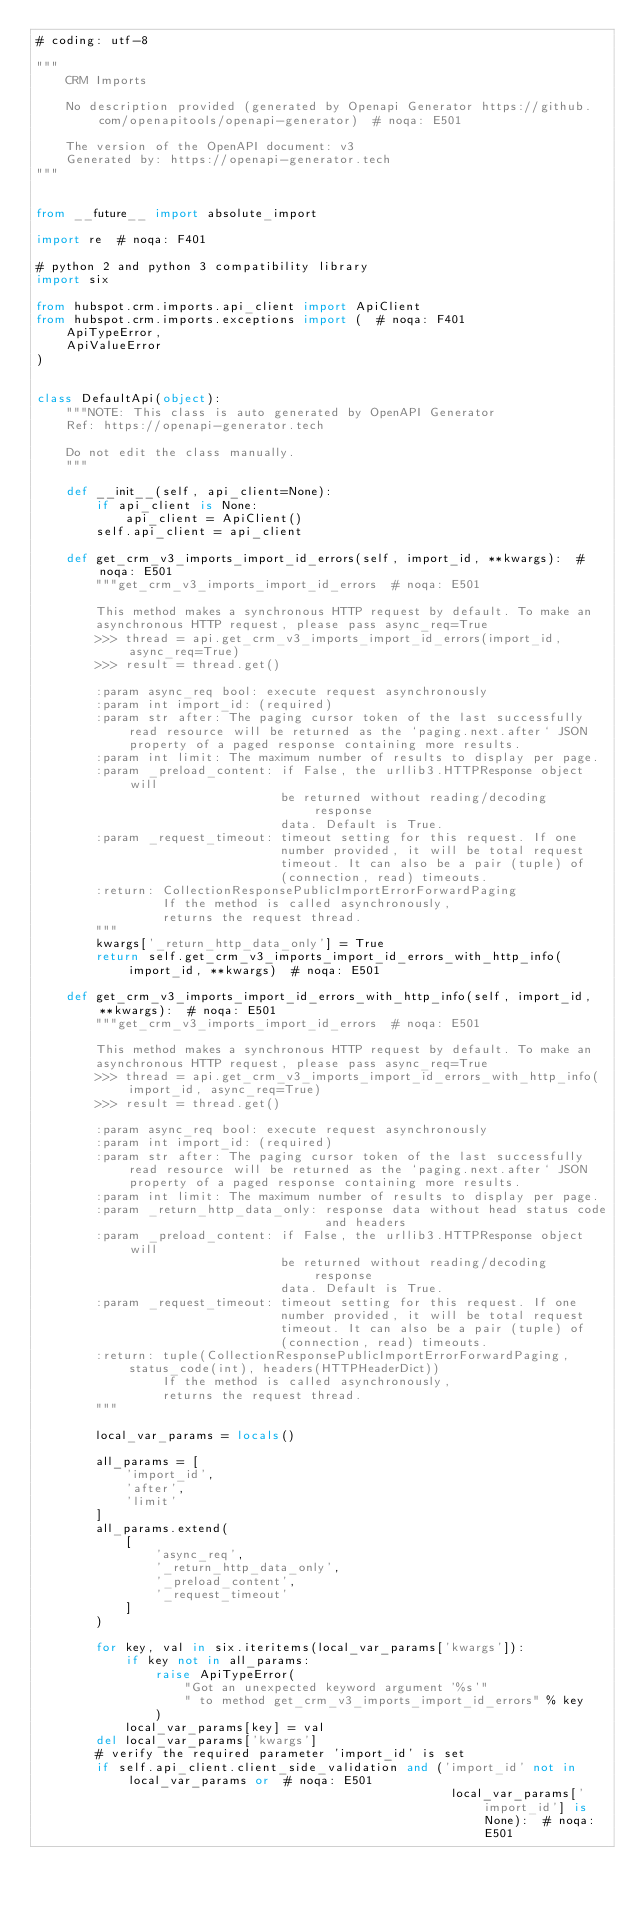Convert code to text. <code><loc_0><loc_0><loc_500><loc_500><_Python_># coding: utf-8

"""
    CRM Imports

    No description provided (generated by Openapi Generator https://github.com/openapitools/openapi-generator)  # noqa: E501

    The version of the OpenAPI document: v3
    Generated by: https://openapi-generator.tech
"""


from __future__ import absolute_import

import re  # noqa: F401

# python 2 and python 3 compatibility library
import six

from hubspot.crm.imports.api_client import ApiClient
from hubspot.crm.imports.exceptions import (  # noqa: F401
    ApiTypeError,
    ApiValueError
)


class DefaultApi(object):
    """NOTE: This class is auto generated by OpenAPI Generator
    Ref: https://openapi-generator.tech

    Do not edit the class manually.
    """

    def __init__(self, api_client=None):
        if api_client is None:
            api_client = ApiClient()
        self.api_client = api_client

    def get_crm_v3_imports_import_id_errors(self, import_id, **kwargs):  # noqa: E501
        """get_crm_v3_imports_import_id_errors  # noqa: E501

        This method makes a synchronous HTTP request by default. To make an
        asynchronous HTTP request, please pass async_req=True
        >>> thread = api.get_crm_v3_imports_import_id_errors(import_id, async_req=True)
        >>> result = thread.get()

        :param async_req bool: execute request asynchronously
        :param int import_id: (required)
        :param str after: The paging cursor token of the last successfully read resource will be returned as the `paging.next.after` JSON property of a paged response containing more results.
        :param int limit: The maximum number of results to display per page.
        :param _preload_content: if False, the urllib3.HTTPResponse object will
                                 be returned without reading/decoding response
                                 data. Default is True.
        :param _request_timeout: timeout setting for this request. If one
                                 number provided, it will be total request
                                 timeout. It can also be a pair (tuple) of
                                 (connection, read) timeouts.
        :return: CollectionResponsePublicImportErrorForwardPaging
                 If the method is called asynchronously,
                 returns the request thread.
        """
        kwargs['_return_http_data_only'] = True
        return self.get_crm_v3_imports_import_id_errors_with_http_info(import_id, **kwargs)  # noqa: E501

    def get_crm_v3_imports_import_id_errors_with_http_info(self, import_id, **kwargs):  # noqa: E501
        """get_crm_v3_imports_import_id_errors  # noqa: E501

        This method makes a synchronous HTTP request by default. To make an
        asynchronous HTTP request, please pass async_req=True
        >>> thread = api.get_crm_v3_imports_import_id_errors_with_http_info(import_id, async_req=True)
        >>> result = thread.get()

        :param async_req bool: execute request asynchronously
        :param int import_id: (required)
        :param str after: The paging cursor token of the last successfully read resource will be returned as the `paging.next.after` JSON property of a paged response containing more results.
        :param int limit: The maximum number of results to display per page.
        :param _return_http_data_only: response data without head status code
                                       and headers
        :param _preload_content: if False, the urllib3.HTTPResponse object will
                                 be returned without reading/decoding response
                                 data. Default is True.
        :param _request_timeout: timeout setting for this request. If one
                                 number provided, it will be total request
                                 timeout. It can also be a pair (tuple) of
                                 (connection, read) timeouts.
        :return: tuple(CollectionResponsePublicImportErrorForwardPaging, status_code(int), headers(HTTPHeaderDict))
                 If the method is called asynchronously,
                 returns the request thread.
        """

        local_var_params = locals()

        all_params = [
            'import_id',
            'after',
            'limit'
        ]
        all_params.extend(
            [
                'async_req',
                '_return_http_data_only',
                '_preload_content',
                '_request_timeout'
            ]
        )

        for key, val in six.iteritems(local_var_params['kwargs']):
            if key not in all_params:
                raise ApiTypeError(
                    "Got an unexpected keyword argument '%s'"
                    " to method get_crm_v3_imports_import_id_errors" % key
                )
            local_var_params[key] = val
        del local_var_params['kwargs']
        # verify the required parameter 'import_id' is set
        if self.api_client.client_side_validation and ('import_id' not in local_var_params or  # noqa: E501
                                                        local_var_params['import_id'] is None):  # noqa: E501</code> 